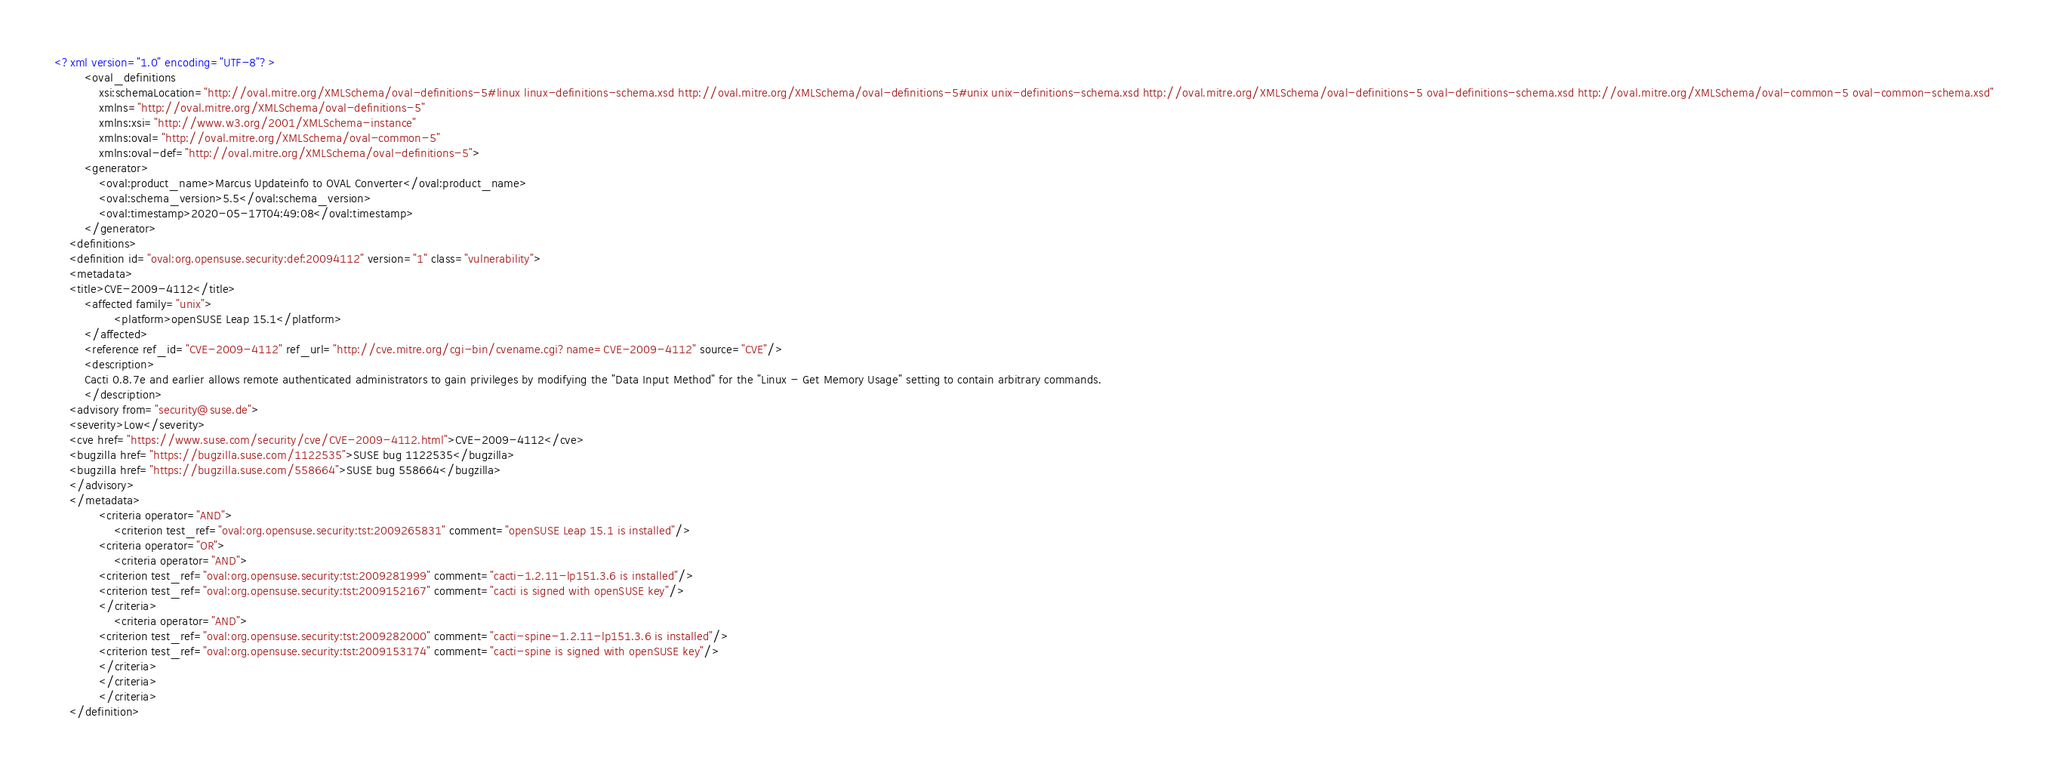<code> <loc_0><loc_0><loc_500><loc_500><_XML_><?xml version="1.0" encoding="UTF-8"?>
        <oval_definitions
            xsi:schemaLocation="http://oval.mitre.org/XMLSchema/oval-definitions-5#linux linux-definitions-schema.xsd http://oval.mitre.org/XMLSchema/oval-definitions-5#unix unix-definitions-schema.xsd http://oval.mitre.org/XMLSchema/oval-definitions-5 oval-definitions-schema.xsd http://oval.mitre.org/XMLSchema/oval-common-5 oval-common-schema.xsd"
            xmlns="http://oval.mitre.org/XMLSchema/oval-definitions-5"
            xmlns:xsi="http://www.w3.org/2001/XMLSchema-instance"
            xmlns:oval="http://oval.mitre.org/XMLSchema/oval-common-5"
            xmlns:oval-def="http://oval.mitre.org/XMLSchema/oval-definitions-5">
        <generator>
            <oval:product_name>Marcus Updateinfo to OVAL Converter</oval:product_name>
            <oval:schema_version>5.5</oval:schema_version>
            <oval:timestamp>2020-05-17T04:49:08</oval:timestamp>
        </generator>
    <definitions>
    <definition id="oval:org.opensuse.security:def:20094112" version="1" class="vulnerability">
    <metadata>
    <title>CVE-2009-4112</title>
        <affected family="unix">
                <platform>openSUSE Leap 15.1</platform>
        </affected>
        <reference ref_id="CVE-2009-4112" ref_url="http://cve.mitre.org/cgi-bin/cvename.cgi?name=CVE-2009-4112" source="CVE"/>
        <description>
        Cacti 0.8.7e and earlier allows remote authenticated administrators to gain privileges by modifying the "Data Input Method" for the "Linux - Get Memory Usage" setting to contain arbitrary commands.
        </description>
    <advisory from="security@suse.de">
    <severity>Low</severity>
    <cve href="https://www.suse.com/security/cve/CVE-2009-4112.html">CVE-2009-4112</cve>
    <bugzilla href="https://bugzilla.suse.com/1122535">SUSE bug 1122535</bugzilla>
    <bugzilla href="https://bugzilla.suse.com/558664">SUSE bug 558664</bugzilla>
    </advisory>
    </metadata>
            <criteria operator="AND">
                <criterion test_ref="oval:org.opensuse.security:tst:2009265831" comment="openSUSE Leap 15.1 is installed"/>
            <criteria operator="OR">
                <criteria operator="AND">
            <criterion test_ref="oval:org.opensuse.security:tst:2009281999" comment="cacti-1.2.11-lp151.3.6 is installed"/>
            <criterion test_ref="oval:org.opensuse.security:tst:2009152167" comment="cacti is signed with openSUSE key"/>
            </criteria>
                <criteria operator="AND">
            <criterion test_ref="oval:org.opensuse.security:tst:2009282000" comment="cacti-spine-1.2.11-lp151.3.6 is installed"/>
            <criterion test_ref="oval:org.opensuse.security:tst:2009153174" comment="cacti-spine is signed with openSUSE key"/>
            </criteria>
            </criteria>
            </criteria>
    </definition></code> 